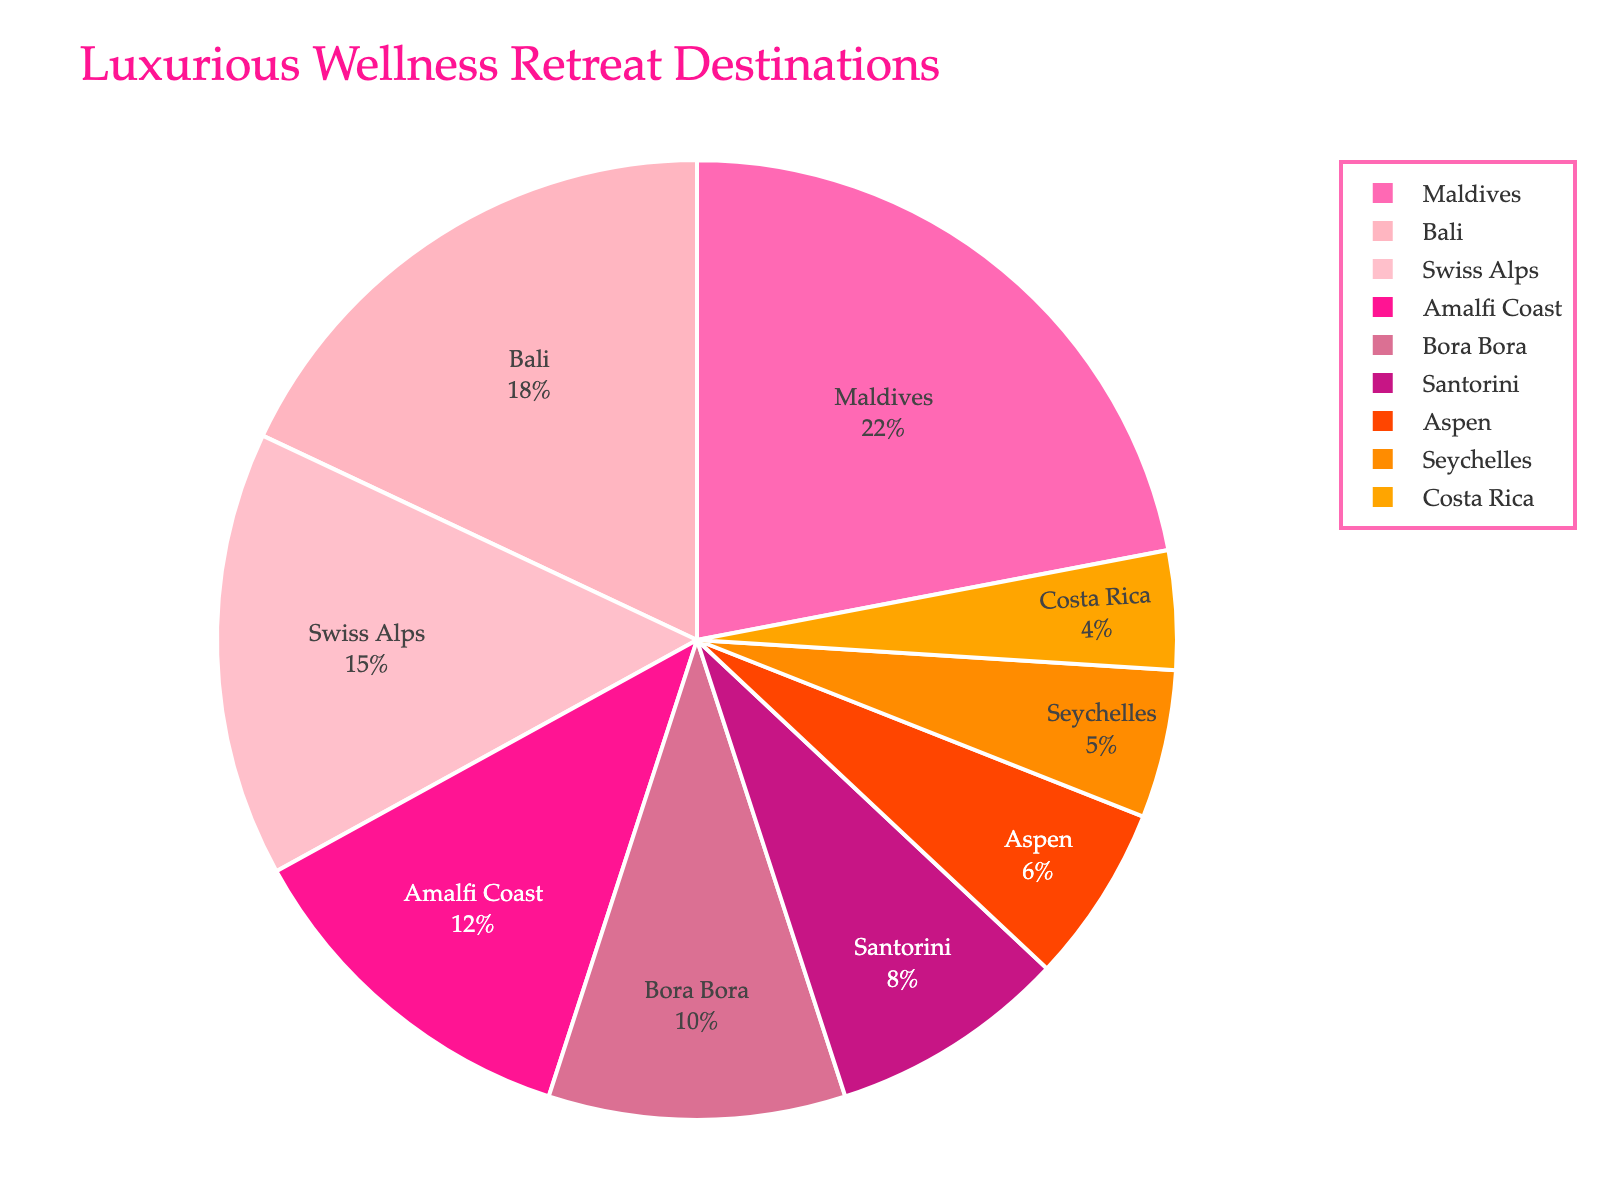Which destination has the highest percentage of visits by influencers? The largest segment of the pie chart represents Maldives, which corresponds to the highest percentage.
Answer: Maldives Which destination is visited less than Bora Bora but more than Seychelles? Checking the segments, Bora Bora has 10%, Seychelles has 5%, and Santorini falls between them with 8% as it has a smaller segment than Bora Bora yet larger than Seychelles.
Answer: Santorini What's the combined percentage of visits to Bali and Aspen? Bali has 18% and Aspen has 6%. Adding these percentages gives 18 + 6 = 24.
Answer: 24% How much greater is the percentage of visits to the Maldives compared to the Amalfi Coast? The Maldives has 22% and the Amalfi Coast has 12%. The difference is 22 - 12 = 10.
Answer: 10% How many destinations have a smaller percentage of visits compared to Santorini? Santorini has 8%. Destinations with smaller percentages are Aspen (6%), Seychelles (5%), and Costa Rica (4%), totaling three destinations.
Answer: 3 Which two destinations together make up exactly 30% of the visits? The percentages for Bora Bora and Swiss Alps (10% + 15%) sum up to 25%, but the combination of Swiss Alps (15%) and Amalfi Coast (12%) sums to 27%. Checking Maldives (22%) and Seychelles (5%) gives 27%, none of which add up to exactly 30%. Upon further checking, Bali (18%) and Bora Bora (10%) together make exactly 28%. Hence, no exact pair sums to 30% directly as per given segments.
Answer: None What is the second most visited wellness retreat destination? The destination with the second largest segment after Maldives (22%) is Bali, which has 18%.
Answer: Bali What is the average percentage of visits for Bora Bora, Santorini, and Costa Rica? Adding up the percentages: Bora Bora (10%), Santorini (8%), and Costa Rica (4%), we get a total of 22%. Dividing by the number of destinations (3) gives 22 / 3 = 7.33.
Answer: 7.33% Which destinations occupy the smallest and largest segment in the chart respectively? The Maldives occupies the largest segment at 22%, and Costa Rica occupies the smallest at 4%.
Answer: Maldives, Costa Rica 